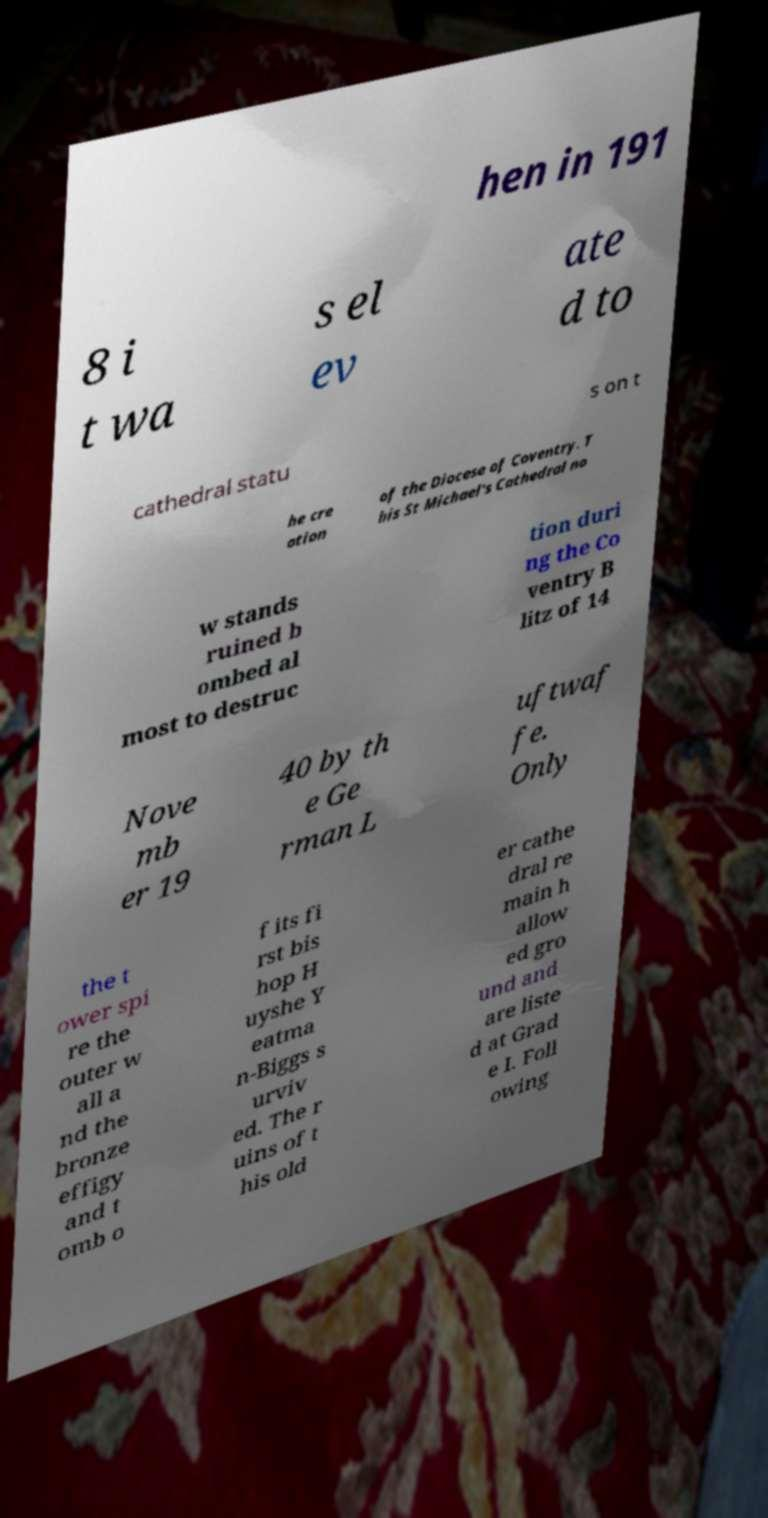I need the written content from this picture converted into text. Can you do that? hen in 191 8 i t wa s el ev ate d to cathedral statu s on t he cre ation of the Diocese of Coventry. T his St Michael's Cathedral no w stands ruined b ombed al most to destruc tion duri ng the Co ventry B litz of 14 Nove mb er 19 40 by th e Ge rman L uftwaf fe. Only the t ower spi re the outer w all a nd the bronze effigy and t omb o f its fi rst bis hop H uyshe Y eatma n-Biggs s urviv ed. The r uins of t his old er cathe dral re main h allow ed gro und and are liste d at Grad e I. Foll owing 